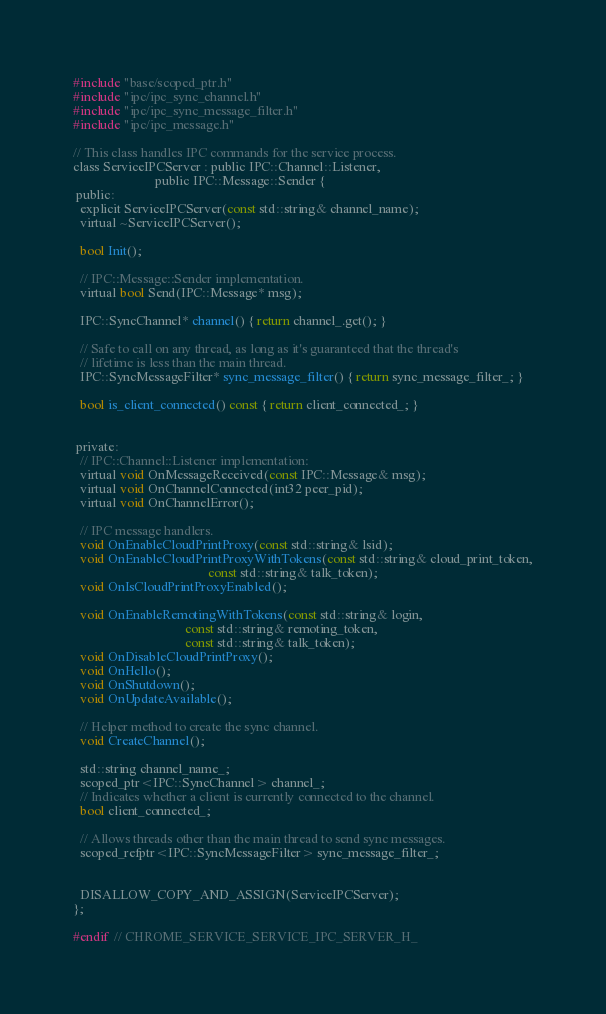<code> <loc_0><loc_0><loc_500><loc_500><_C_>#include "base/scoped_ptr.h"
#include "ipc/ipc_sync_channel.h"
#include "ipc/ipc_sync_message_filter.h"
#include "ipc/ipc_message.h"

// This class handles IPC commands for the service process.
class ServiceIPCServer : public IPC::Channel::Listener,
                         public IPC::Message::Sender {
 public:
  explicit ServiceIPCServer(const std::string& channel_name);
  virtual ~ServiceIPCServer();

  bool Init();

  // IPC::Message::Sender implementation.
  virtual bool Send(IPC::Message* msg);

  IPC::SyncChannel* channel() { return channel_.get(); }

  // Safe to call on any thread, as long as it's guaranteed that the thread's
  // lifetime is less than the main thread.
  IPC::SyncMessageFilter* sync_message_filter() { return sync_message_filter_; }

  bool is_client_connected() const { return client_connected_; }


 private:
  // IPC::Channel::Listener implementation:
  virtual void OnMessageReceived(const IPC::Message& msg);
  virtual void OnChannelConnected(int32 peer_pid);
  virtual void OnChannelError();

  // IPC message handlers.
  void OnEnableCloudPrintProxy(const std::string& lsid);
  void OnEnableCloudPrintProxyWithTokens(const std::string& cloud_print_token,
                                         const std::string& talk_token);
  void OnIsCloudPrintProxyEnabled();

  void OnEnableRemotingWithTokens(const std::string& login,
                                  const std::string& remoting_token,
                                  const std::string& talk_token);
  void OnDisableCloudPrintProxy();
  void OnHello();
  void OnShutdown();
  void OnUpdateAvailable();

  // Helper method to create the sync channel.
  void CreateChannel();

  std::string channel_name_;
  scoped_ptr<IPC::SyncChannel> channel_;
  // Indicates whether a client is currently connected to the channel.
  bool client_connected_;

  // Allows threads other than the main thread to send sync messages.
  scoped_refptr<IPC::SyncMessageFilter> sync_message_filter_;


  DISALLOW_COPY_AND_ASSIGN(ServiceIPCServer);
};

#endif  // CHROME_SERVICE_SERVICE_IPC_SERVER_H_
</code> 